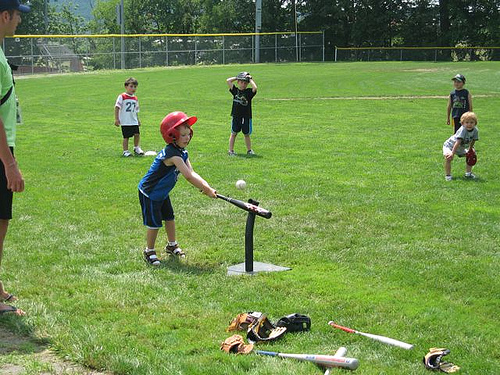Identify the text contained in this image. 27 